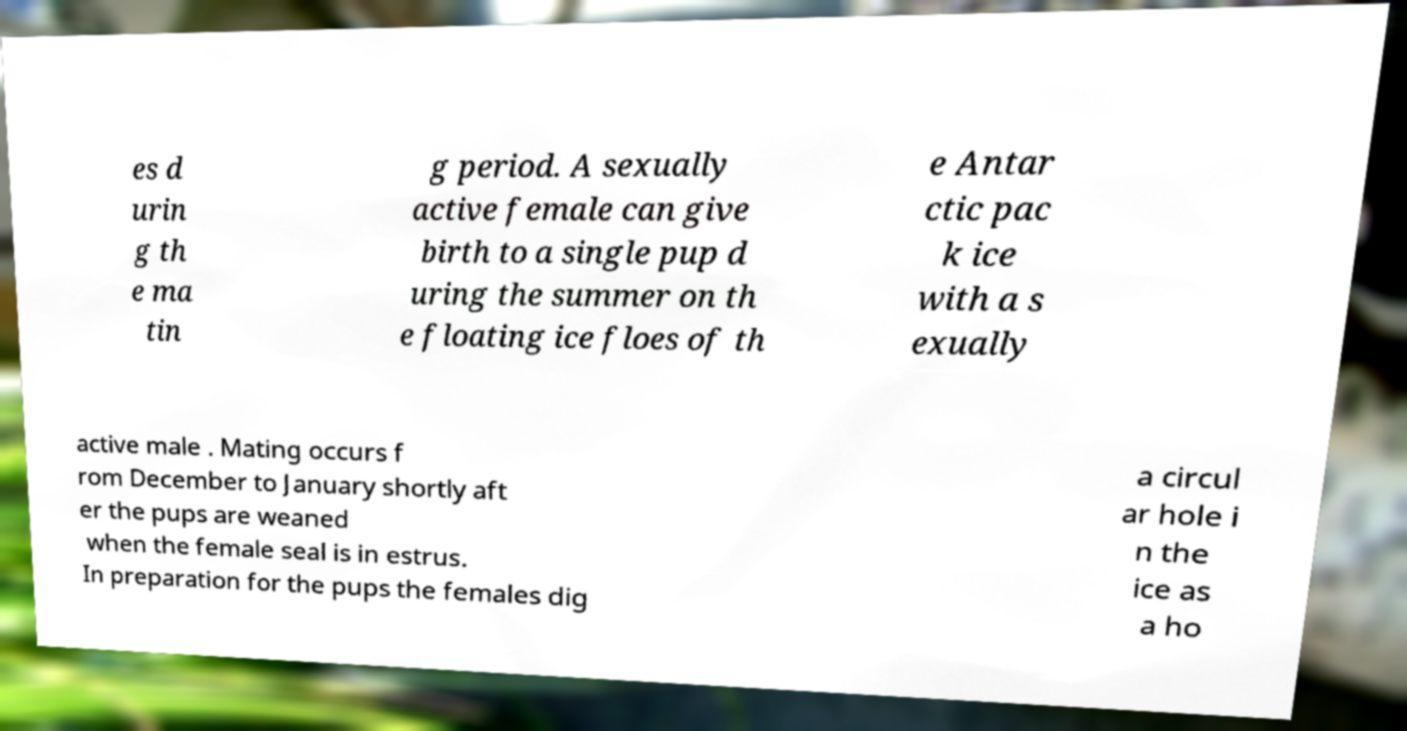Please read and relay the text visible in this image. What does it say? es d urin g th e ma tin g period. A sexually active female can give birth to a single pup d uring the summer on th e floating ice floes of th e Antar ctic pac k ice with a s exually active male . Mating occurs f rom December to January shortly aft er the pups are weaned when the female seal is in estrus. In preparation for the pups the females dig a circul ar hole i n the ice as a ho 